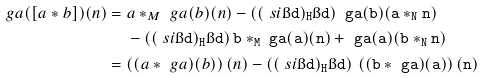<formula> <loc_0><loc_0><loc_500><loc_500>\ g a ( [ a * b ] ) ( n ) & = a * _ { M } \ g a ( b ) ( n ) - ( ( \ s i \tt \i d ) \tt _ { H } \i d ) \, \ g a ( b ) ( a * _ { N } n ) \\ & \quad \, - ( ( \ s i \tt \i d ) \tt _ { H } \i d ) \, b * _ { M } \ g a ( a ) ( n ) + \ g a ( a ) ( b * _ { N } n ) \\ & = \left ( ( a * \ g a ) ( b ) \right ) ( n ) - ( ( \ s i \tt \i d ) \tt _ { H } \i d ) \, \left ( ( b * \ g a ) ( a ) \right ) ( n )</formula> 